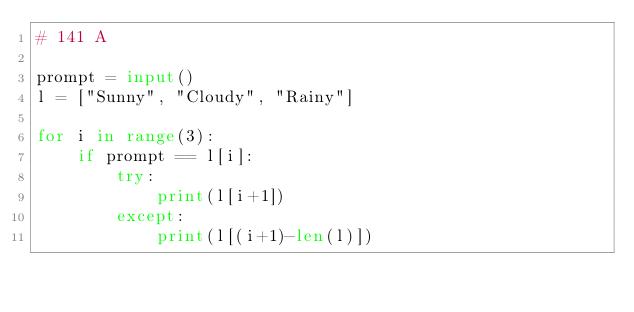Convert code to text. <code><loc_0><loc_0><loc_500><loc_500><_Python_># 141 A

prompt = input()
l = ["Sunny", "Cloudy", "Rainy"]

for i in range(3):
    if prompt == l[i]:
        try:
            print(l[i+1])
        except:
            print(l[(i+1)-len(l)])</code> 